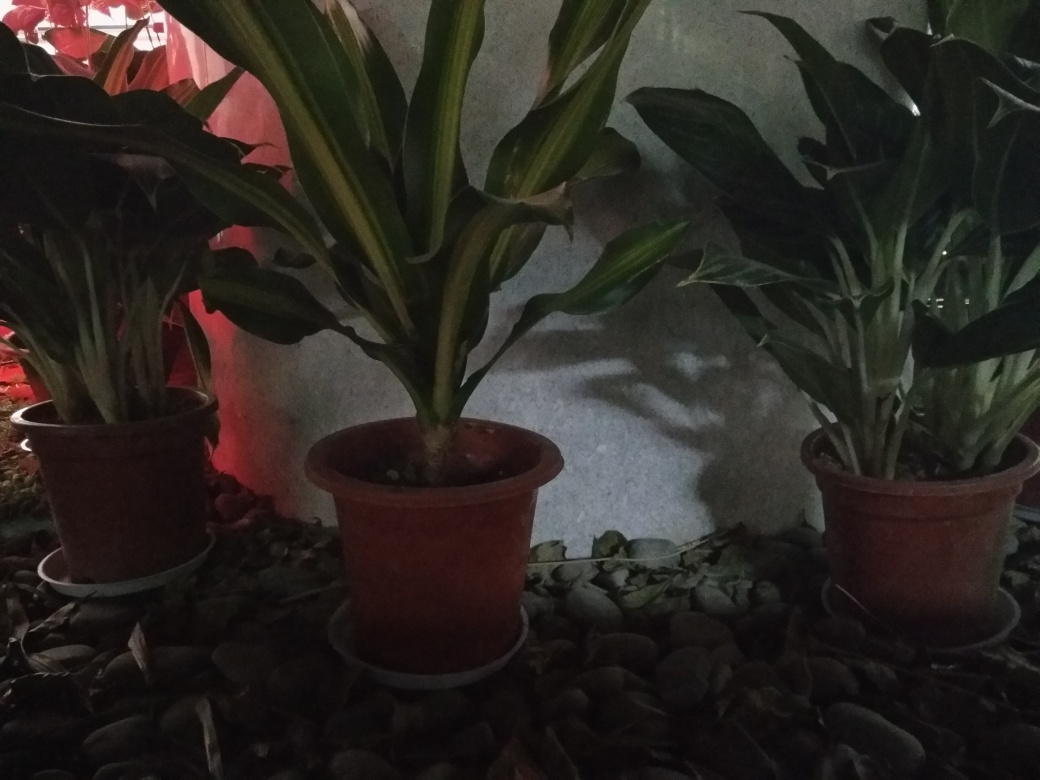Is the quality of this photo acceptable? The quality of the photo is generally acceptable with the image being in focus, capturing the plants and the surrounding details clearly enough for general purposes. However, improvements could be made with regard to the lighting, as the image is quite dark, potentially obscuring finer details. 